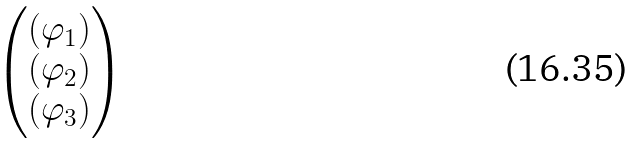<formula> <loc_0><loc_0><loc_500><loc_500>\begin{pmatrix} ( \varphi _ { 1 } ) \\ ( \varphi _ { 2 } ) \\ ( \varphi _ { 3 } ) \end{pmatrix}</formula> 